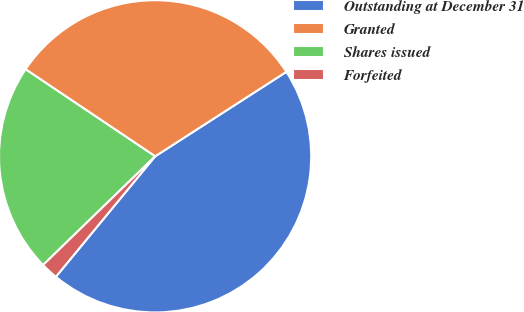Convert chart to OTSL. <chart><loc_0><loc_0><loc_500><loc_500><pie_chart><fcel>Outstanding at December 31<fcel>Granted<fcel>Shares issued<fcel>Forfeited<nl><fcel>45.07%<fcel>31.48%<fcel>21.67%<fcel>1.77%<nl></chart> 